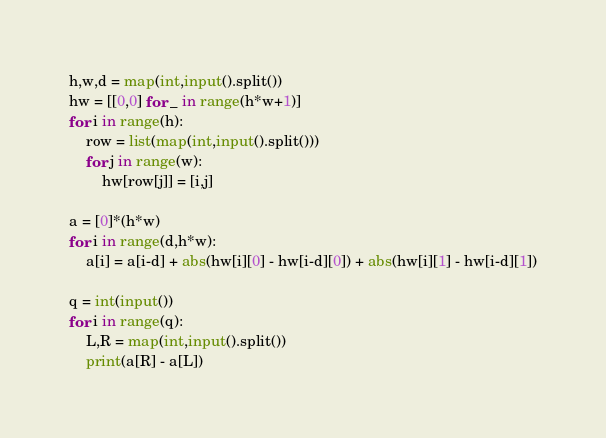Convert code to text. <code><loc_0><loc_0><loc_500><loc_500><_Python_>h,w,d = map(int,input().split())
hw = [[0,0] for _ in range(h*w+1)]
for i in range(h):
    row = list(map(int,input().split()))
    for j in range(w):
        hw[row[j]] = [i,j]

a = [0]*(h*w)
for i in range(d,h*w):
    a[i] = a[i-d] + abs(hw[i][0] - hw[i-d][0]) + abs(hw[i][1] - hw[i-d][1])

q = int(input())
for i in range(q):
    L,R = map(int,input().split())
    print(a[R] - a[L])</code> 